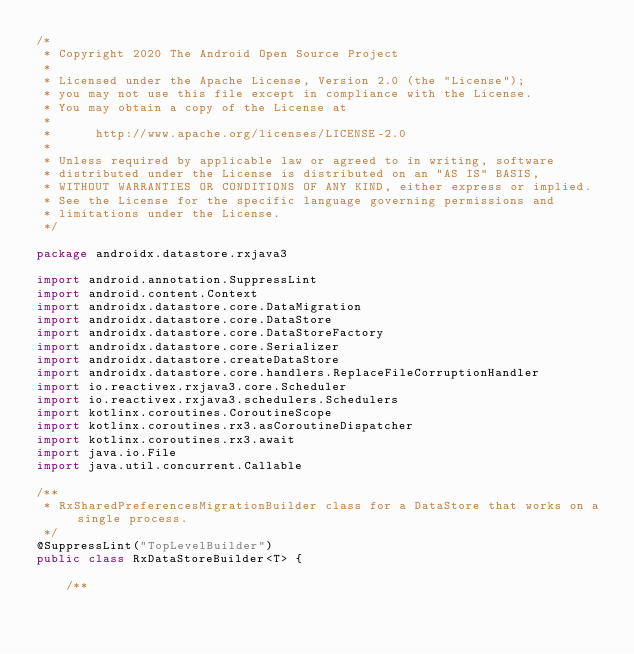<code> <loc_0><loc_0><loc_500><loc_500><_Kotlin_>/*
 * Copyright 2020 The Android Open Source Project
 *
 * Licensed under the Apache License, Version 2.0 (the "License");
 * you may not use this file except in compliance with the License.
 * You may obtain a copy of the License at
 *
 *      http://www.apache.org/licenses/LICENSE-2.0
 *
 * Unless required by applicable law or agreed to in writing, software
 * distributed under the License is distributed on an "AS IS" BASIS,
 * WITHOUT WARRANTIES OR CONDITIONS OF ANY KIND, either express or implied.
 * See the License for the specific language governing permissions and
 * limitations under the License.
 */

package androidx.datastore.rxjava3

import android.annotation.SuppressLint
import android.content.Context
import androidx.datastore.core.DataMigration
import androidx.datastore.core.DataStore
import androidx.datastore.core.DataStoreFactory
import androidx.datastore.core.Serializer
import androidx.datastore.createDataStore
import androidx.datastore.core.handlers.ReplaceFileCorruptionHandler
import io.reactivex.rxjava3.core.Scheduler
import io.reactivex.rxjava3.schedulers.Schedulers
import kotlinx.coroutines.CoroutineScope
import kotlinx.coroutines.rx3.asCoroutineDispatcher
import kotlinx.coroutines.rx3.await
import java.io.File
import java.util.concurrent.Callable

/**
 * RxSharedPreferencesMigrationBuilder class for a DataStore that works on a single process.
 */
@SuppressLint("TopLevelBuilder")
public class RxDataStoreBuilder<T> {

    /**</code> 